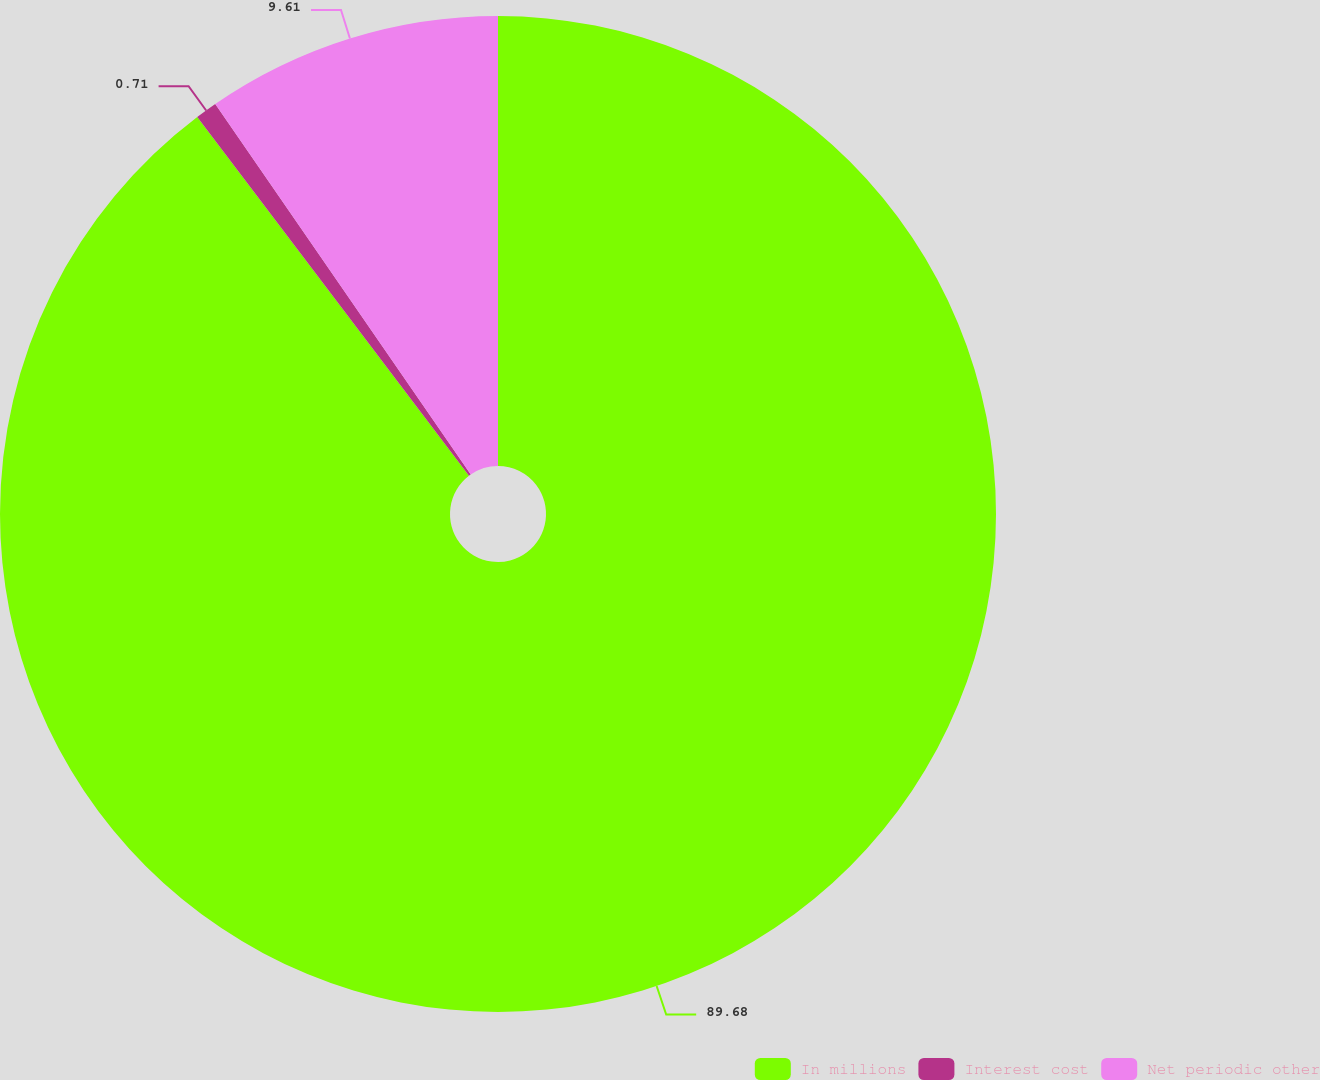<chart> <loc_0><loc_0><loc_500><loc_500><pie_chart><fcel>In millions<fcel>Interest cost<fcel>Net periodic other<nl><fcel>89.68%<fcel>0.71%<fcel>9.61%<nl></chart> 